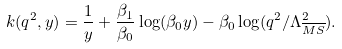Convert formula to latex. <formula><loc_0><loc_0><loc_500><loc_500>k ( q ^ { 2 } , y ) = \frac { 1 } { y } + \frac { \beta _ { 1 } } { \beta _ { 0 } } \log ( \beta _ { 0 } y ) - \beta _ { 0 } \log ( q ^ { 2 } / \Lambda _ { \overline { M S } } ^ { 2 } ) .</formula> 